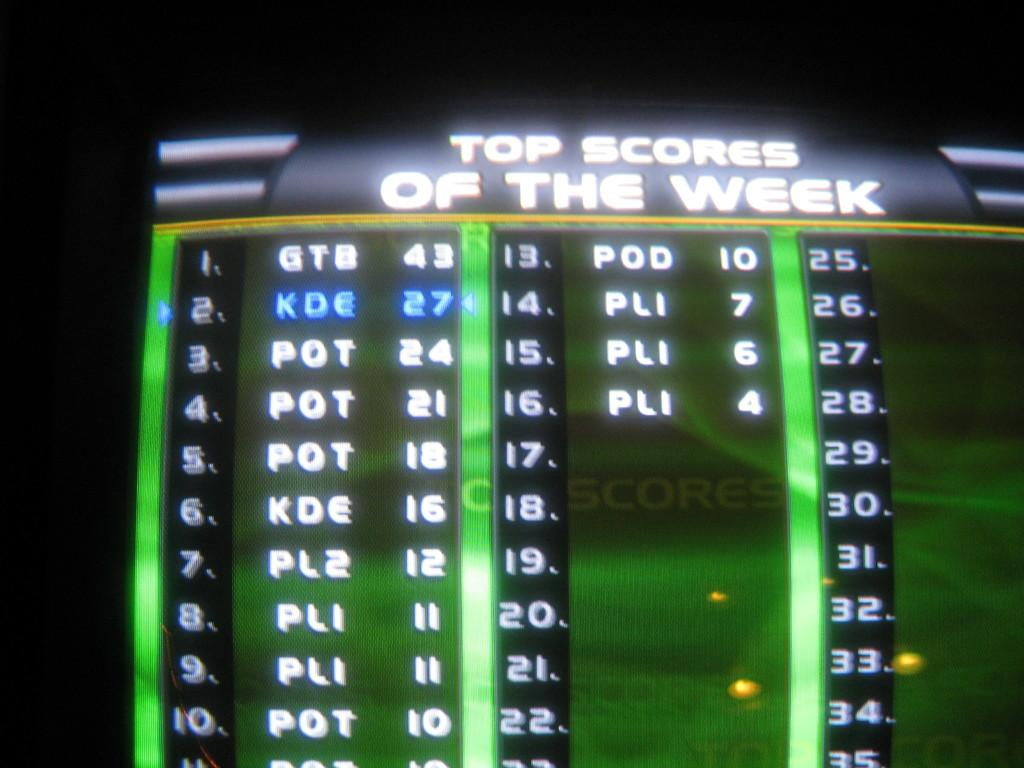What can be seen in the image that displays information? There is a display device in the image. What is visible on the display device? The display device has text on it. How does the father interact with the display device in the image? There is no father present in the image, and therefore no interaction can be observed. 